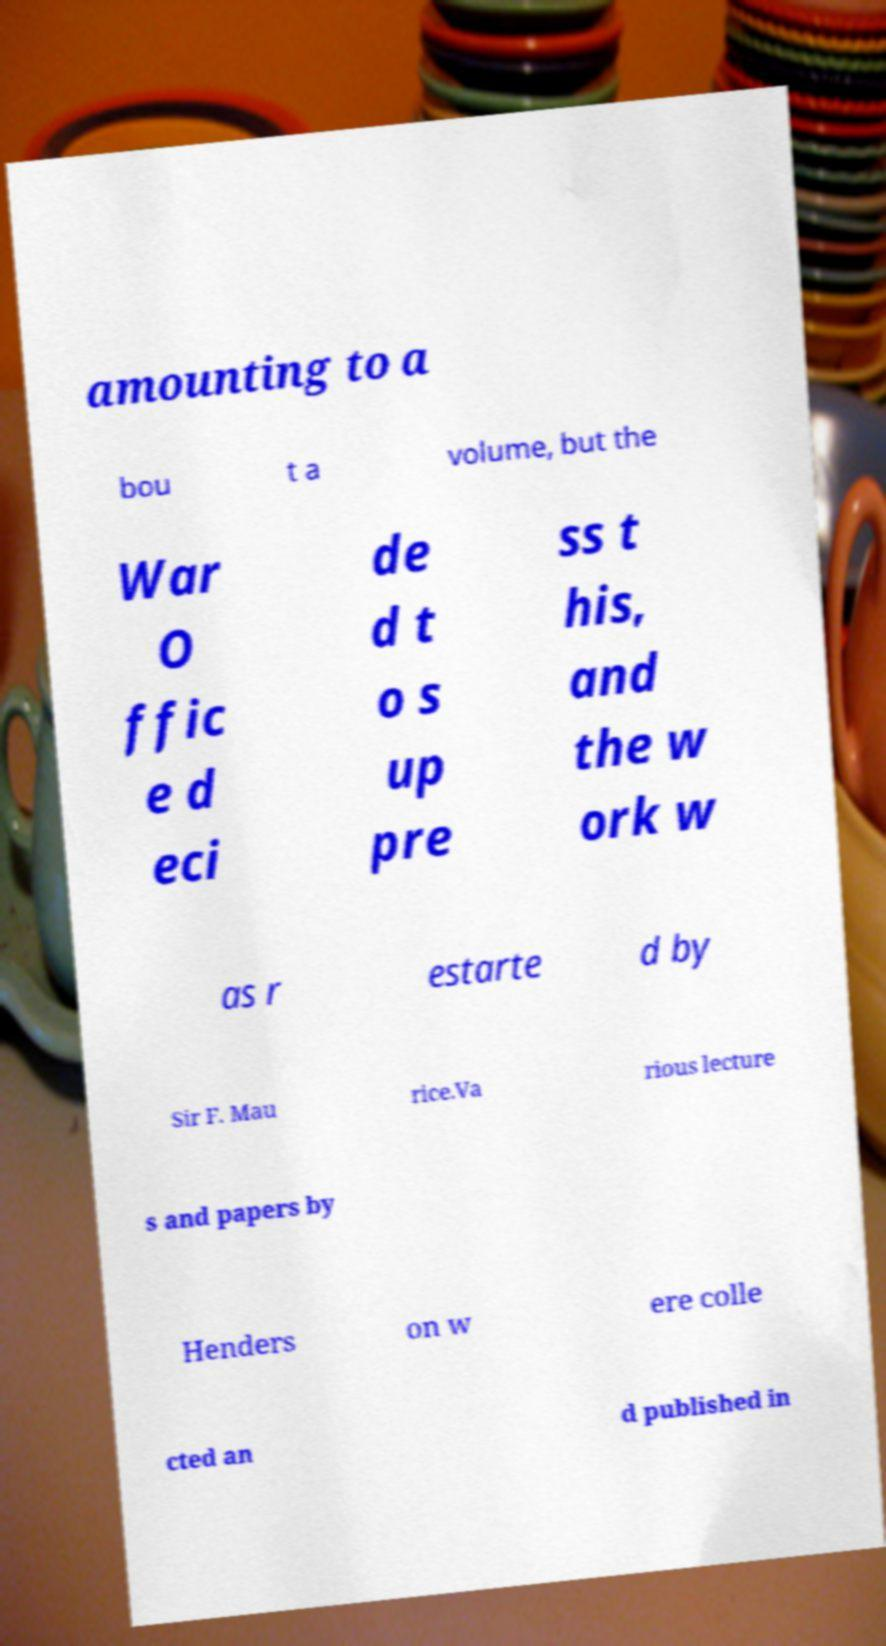For documentation purposes, I need the text within this image transcribed. Could you provide that? amounting to a bou t a volume, but the War O ffic e d eci de d t o s up pre ss t his, and the w ork w as r estarte d by Sir F. Mau rice.Va rious lecture s and papers by Henders on w ere colle cted an d published in 